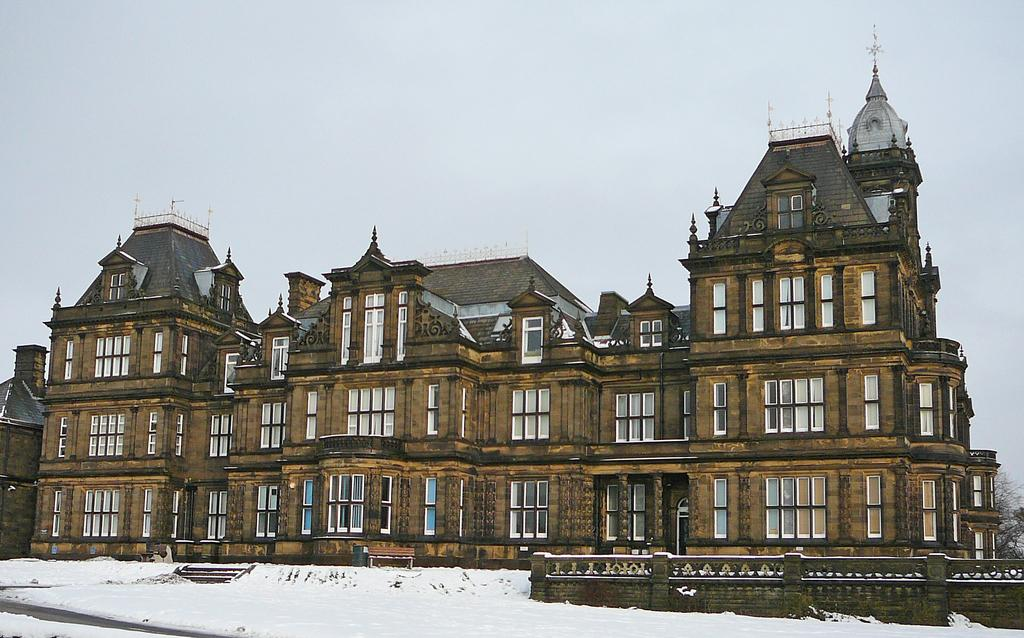What type of structure is visible in the image? There is a building with windows in the image. What is the condition of the ground in the image? There is snow on the ground in the image. What architectural feature can be seen in the image? There is a wall in the image. What can be seen in the background of the image? The sky is visible in the background of the image. What type of yarn is being used to decorate the building in the image? There is no yarn present in the image. --- Facts: 1. There is a person in the image. 2. The person is wearing a hat. 3. The person is holding a book. 4. There is a table in the image. 5. The table has a lamp on it. Absurd Topics: unicorn, trampoline, turtle Conversation: Who or what is the main subject in the image? The main subject in the image is a person. What is the person wearing in the image? The person is wearing a hat in the image. What object is the person holding in the image? The person is holding a book in the image. What type of furniture is present in the image? There is a table present in the image. What object is placed on the table in the image? The table has a lamp on it in the image. Reasoning: Let's think step by step in order to produce the conversation. We start by identifying the main subject of the image, which is a person. Next, we describe the person's attire, noting that they are wearing a hat. Then, we observe the actions of the person, noting that they are holding a book. After that, we describe the furniture present in the image, which is a table. Finally, we describe the object placed on the table in the image, which is a lamp. Absurd Question/Answer: Can you see a unicorn jumping on a trampoline in the image? There is no unicorn or trampoline present in the image. --- Facts: 1. There is a group of people in the image. 2. The people are sitting on chairs. 3. There is a table in the image. 4. The table has plates and utensils on it. Absurd Topics: xylophone, yak, zebra Conversation: How many people are present in the image? There is a group of people in the image. What are the people doing in the image? The people are sitting on chairs in the image. What type of furniture is present in the image? There is a table present in the image. What objects are placed on the table in the image? The table has plates and utens 